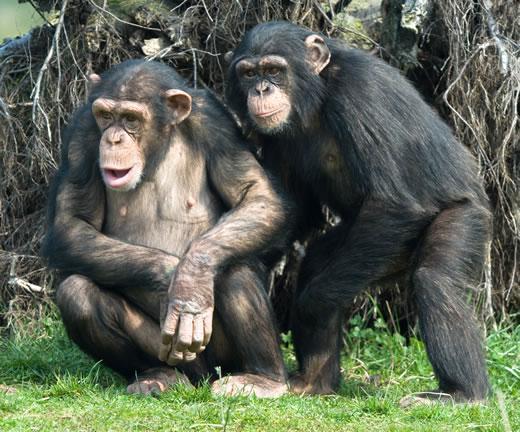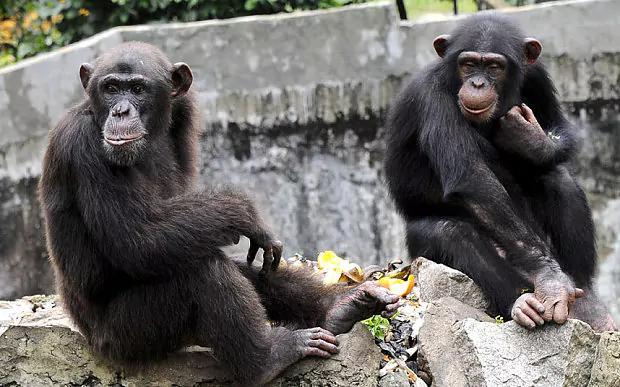The first image is the image on the left, the second image is the image on the right. Assess this claim about the two images: "The image on the right contains two chimpanzees.". Correct or not? Answer yes or no. Yes. The first image is the image on the left, the second image is the image on the right. For the images displayed, is the sentence "An image shows a pair of squatting apes that each hold a food-type item in one hand." factually correct? Answer yes or no. No. The first image is the image on the left, the second image is the image on the right. Examine the images to the left and right. Is the description "Two primates sit in a grassy area in the image on the right." accurate? Answer yes or no. No. The first image is the image on the left, the second image is the image on the right. Assess this claim about the two images: "None of the images has more than two chimpanzees present.". Correct or not? Answer yes or no. Yes. 